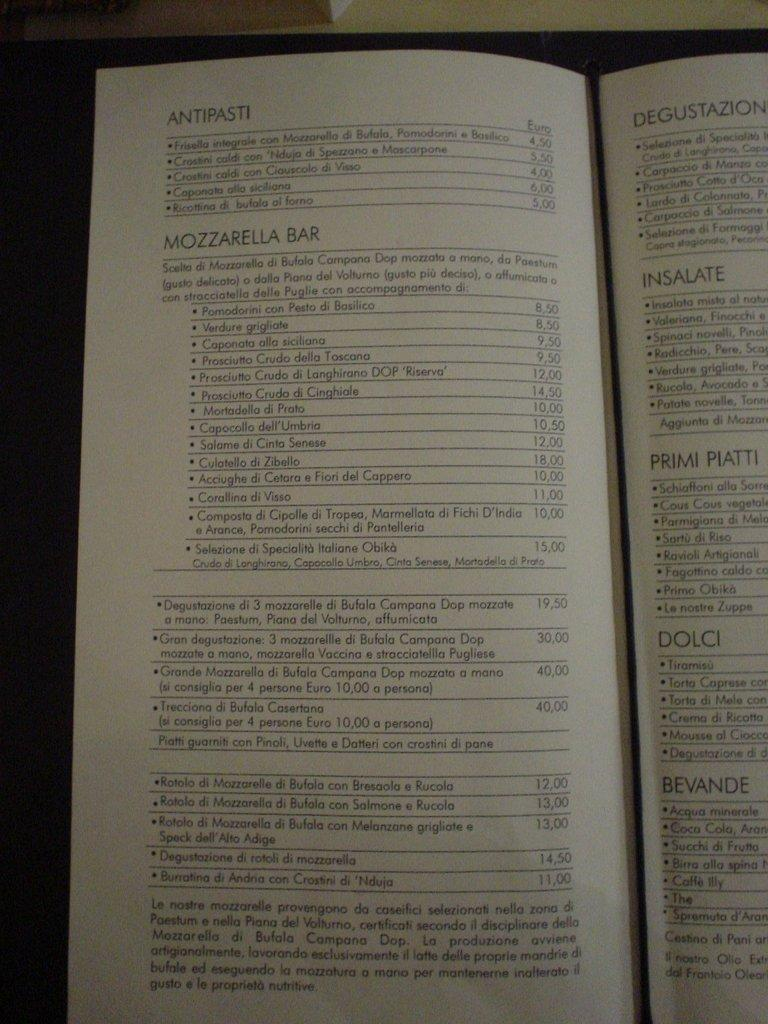Provide a one-sentence caption for the provided image. Antipasti showing the euros and bars that contain types of drinks. 